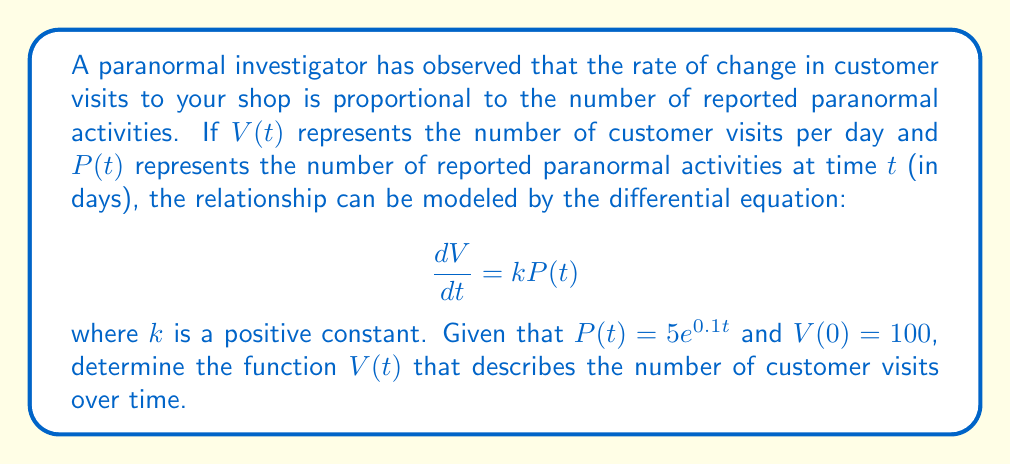Can you answer this question? To solve this first-order differential equation, we'll follow these steps:

1) We're given that $\frac{dV}{dt} = kP(t)$ and $P(t) = 5e^{0.1t}$. Substituting this into our differential equation:

   $$\frac{dV}{dt} = k(5e^{0.1t})$$

2) To solve this, we need to integrate both sides with respect to $t$:

   $$\int \frac{dV}{dt} dt = \int k(5e^{0.1t}) dt$$

3) The left side simplifies to $V$. For the right side:

   $$V = k(5)\int e^{0.1t} dt$$

4) Integrating $e^{0.1t}$:

   $$V = k(5)(\frac{1}{0.1}e^{0.1t}) + C$$

   $$V = 50ke^{0.1t} + C$$

5) To find $C$, we use the initial condition $V(0) = 100$:

   $$100 = 50k(1) + C$$
   $$C = 100 - 50k$$

6) Therefore, our general solution is:

   $$V(t) = 50ke^{0.1t} + (100 - 50k)$$

This is the function that describes the number of customer visits over time based on the reported paranormal activity.
Answer: $V(t) = 50ke^{0.1t} + (100 - 50k)$, where $k$ is a positive constant. 